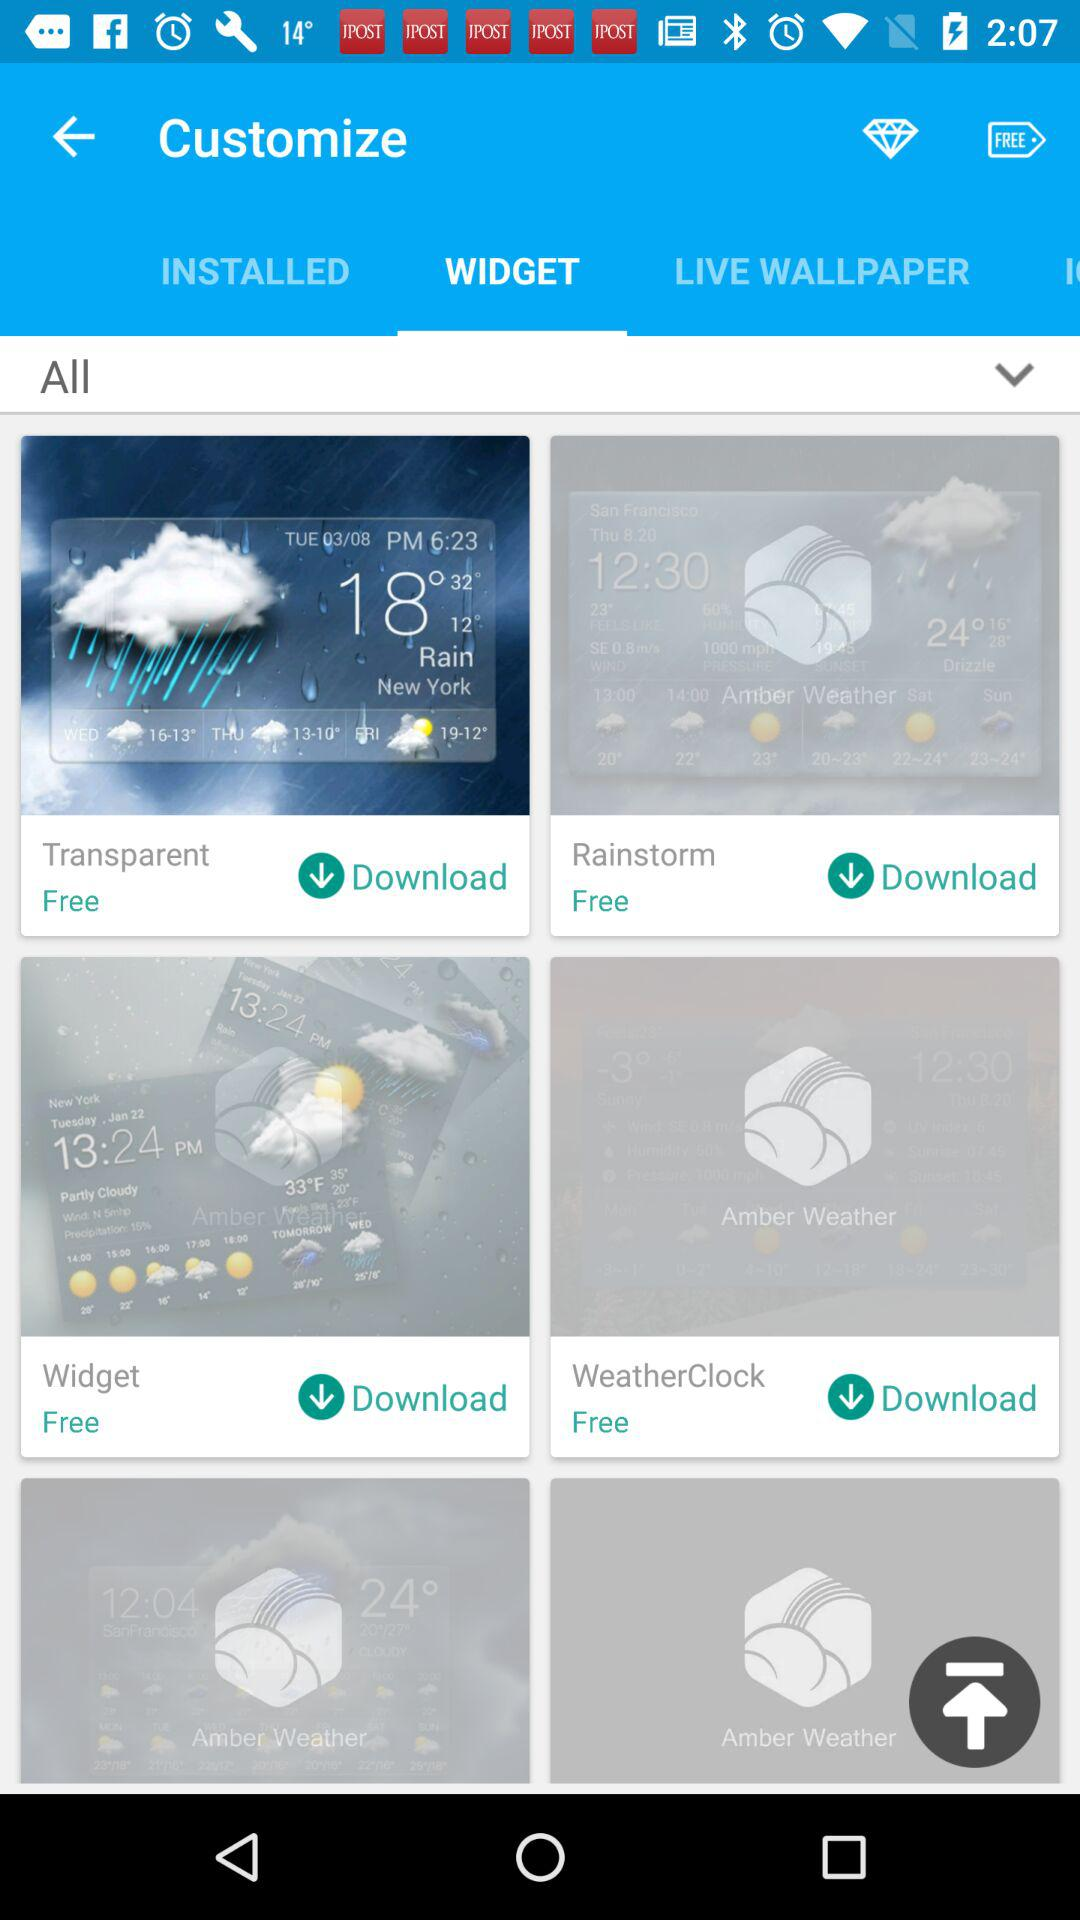Which option is selected in "Customize"? The selected option in "Customize" is "WIDGET". 